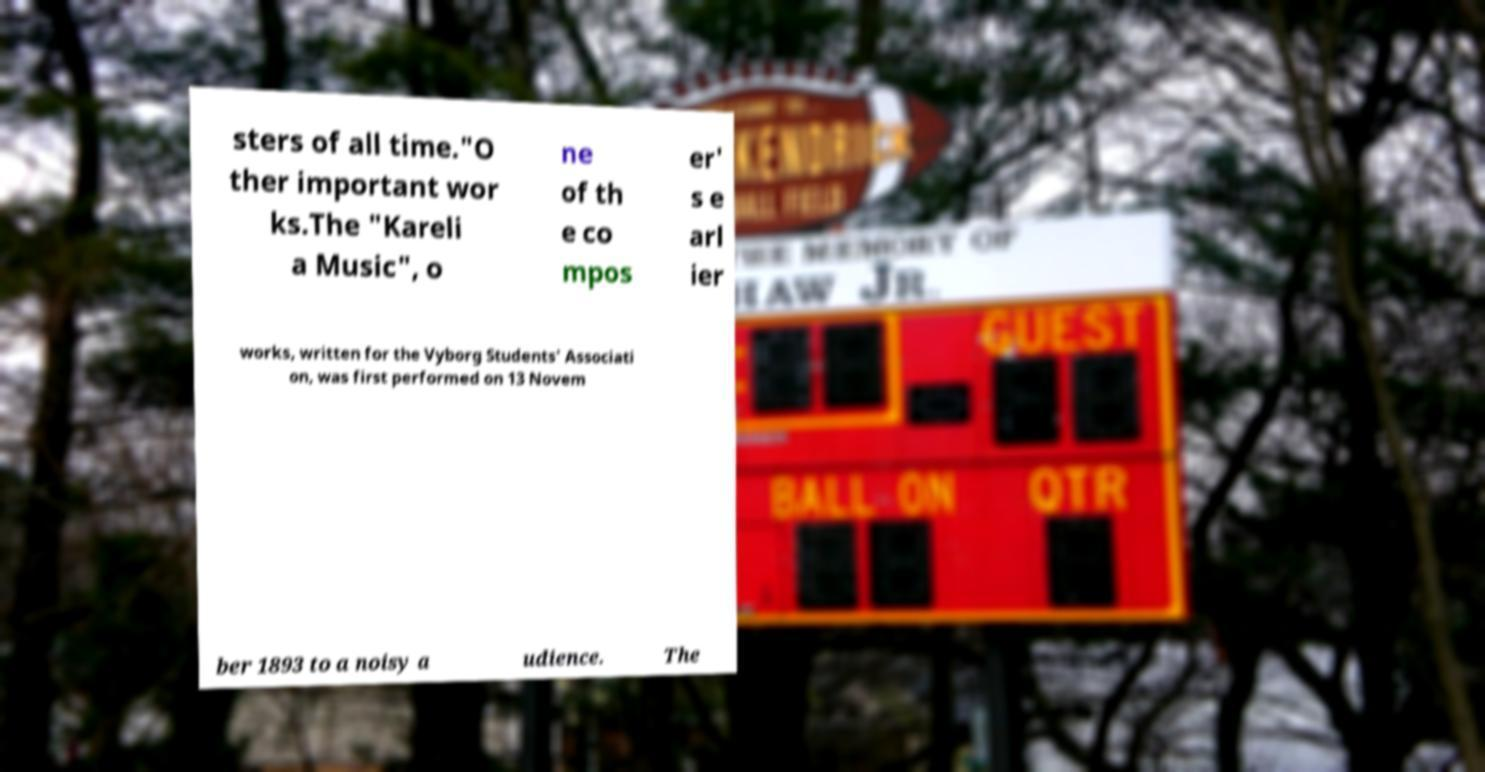What messages or text are displayed in this image? I need them in a readable, typed format. sters of all time."O ther important wor ks.The "Kareli a Music", o ne of th e co mpos er' s e arl ier works, written for the Vyborg Students' Associati on, was first performed on 13 Novem ber 1893 to a noisy a udience. The 